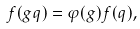<formula> <loc_0><loc_0><loc_500><loc_500>f ( g q ) = \varphi ( g ) f ( q ) ,</formula> 